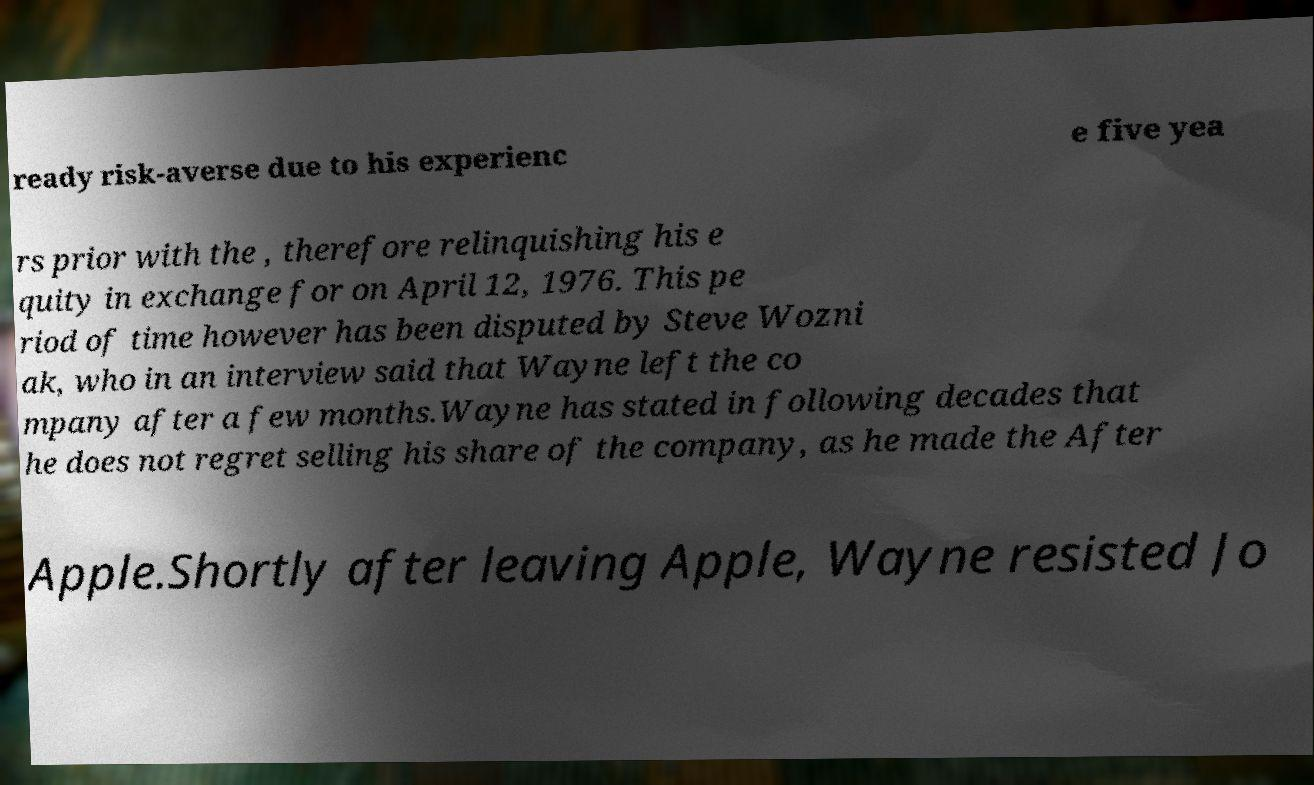What messages or text are displayed in this image? I need them in a readable, typed format. ready risk-averse due to his experienc e five yea rs prior with the , therefore relinquishing his e quity in exchange for on April 12, 1976. This pe riod of time however has been disputed by Steve Wozni ak, who in an interview said that Wayne left the co mpany after a few months.Wayne has stated in following decades that he does not regret selling his share of the company, as he made the After Apple.Shortly after leaving Apple, Wayne resisted Jo 